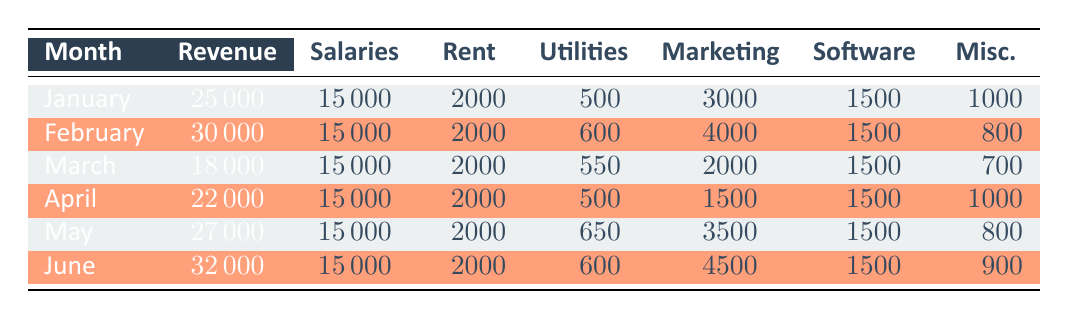How much revenue was generated in June? The table shows the revenue for each month. For June, the revenue is explicitly listed as 32000.
Answer: 32000 What were the total expenses for March? The expenses for March include salaries (15000), rent (2000), utilities (550), marketing (2000), software licenses (1500), and miscellaneous (700). Adding these together gives a total of 15000 + 2000 + 550 + 2000 + 1500 + 700 = 20000.
Answer: 20000 Did the revenue in April exceed the revenue in February? The revenue for April is 22000 and for February it is 30000. Since 22000 is less than 30000, the statement is false.
Answer: No What is the average revenue over the six months? To find the average revenue, sum the monthly revenues (25000 + 30000 + 18000 + 22000 + 27000 + 32000 = 154000) and divide by the number of months (6). Thus, the average revenue is 154000 / 6 = 25666.67, rounded to two decimal points gives 25666.67.
Answer: 25666.67 In which month were the marketing expenses the highest? By comparing the marketing expenses across all months, January (3000), February (4000), March (2000), April (1500), May (3500), and June (4500). June has the highest marketing expenses at 4500.
Answer: June What is the total amount spent on utilities for the first six months? The utilities expenses for each month are: January (500), February (600), March (550), April (500), May (650), June (600). Summing these values gives 500 + 600 + 550 + 500 + 650 + 600 = 3900.
Answer: 3900 Did the studio reduce its expenses from January to February? The total expenses for January are 15000 + 2000 + 500 + 3000 + 1500 + 1000 = 21500 and for February are 15000 + 2000 + 600 + 4000 + 1500 + 800 = 21500. Since both months have the same total expenses, the statement is false.
Answer: No What was the percentage increase in revenue from March to April? The revenue for March is 18000 and for April is 22000. The increase in revenue is 22000 - 18000 = 4000. To find the percentage increase, calculate (4000 / 18000) * 100 ≈ 22.22%.
Answer: 22.22% 